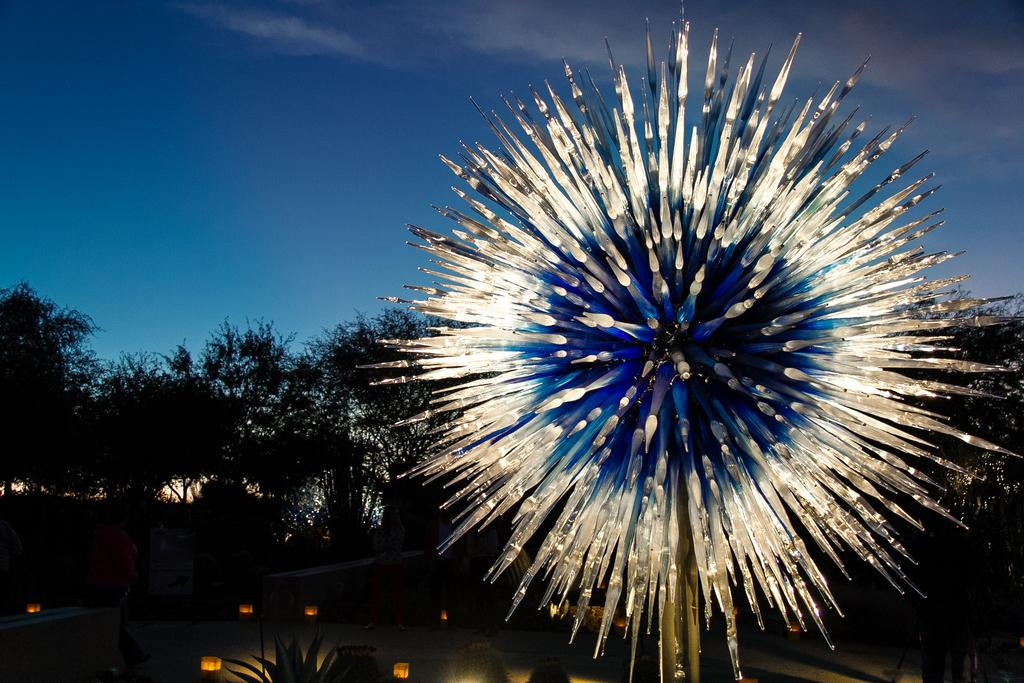What type of vegetation can be seen in the image? There are trees and a plant visible in the image. What else can be seen in the image besides the vegetation? There are lights visible in the image. How would you describe the sky in the image? The sky is blue and cloudy in the image. What type of event is taking place in the image? There is no event taking place in the image; it is a still image of trees, a plant, lights, and a blue and cloudy sky. How many houses are visible in the image? There are no houses visible in the image. 